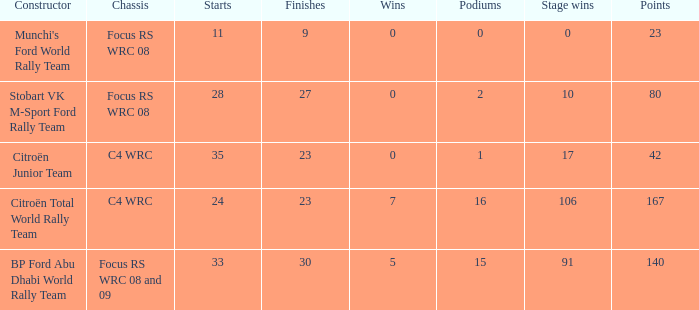What is the highest podiums when the stage wins is 91 and the points is less than 140? None. 